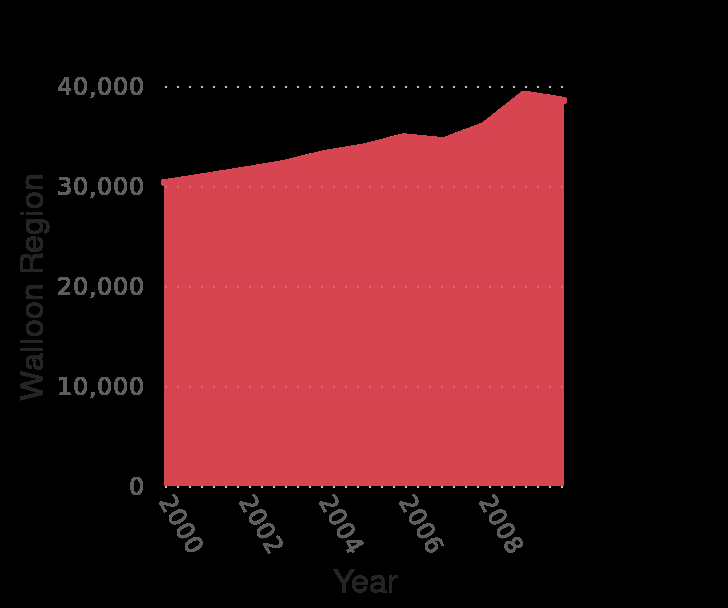<image>
What was the lowest year for annual household disposable income in the Walloon region?  The lowest year for annual household disposable income in the Walloon region was 2000 with 30,000 euros. What was the highest year for annual household disposable income?  The highest year for annual household disposable income was 2008 with almost 40,000 euros. Was the highest year for annual household disposable income in the Walloon region 2000 with 30,000 euros? No. The lowest year for annual household disposable income in the Walloon region was 2000 with 30,000 euros. 